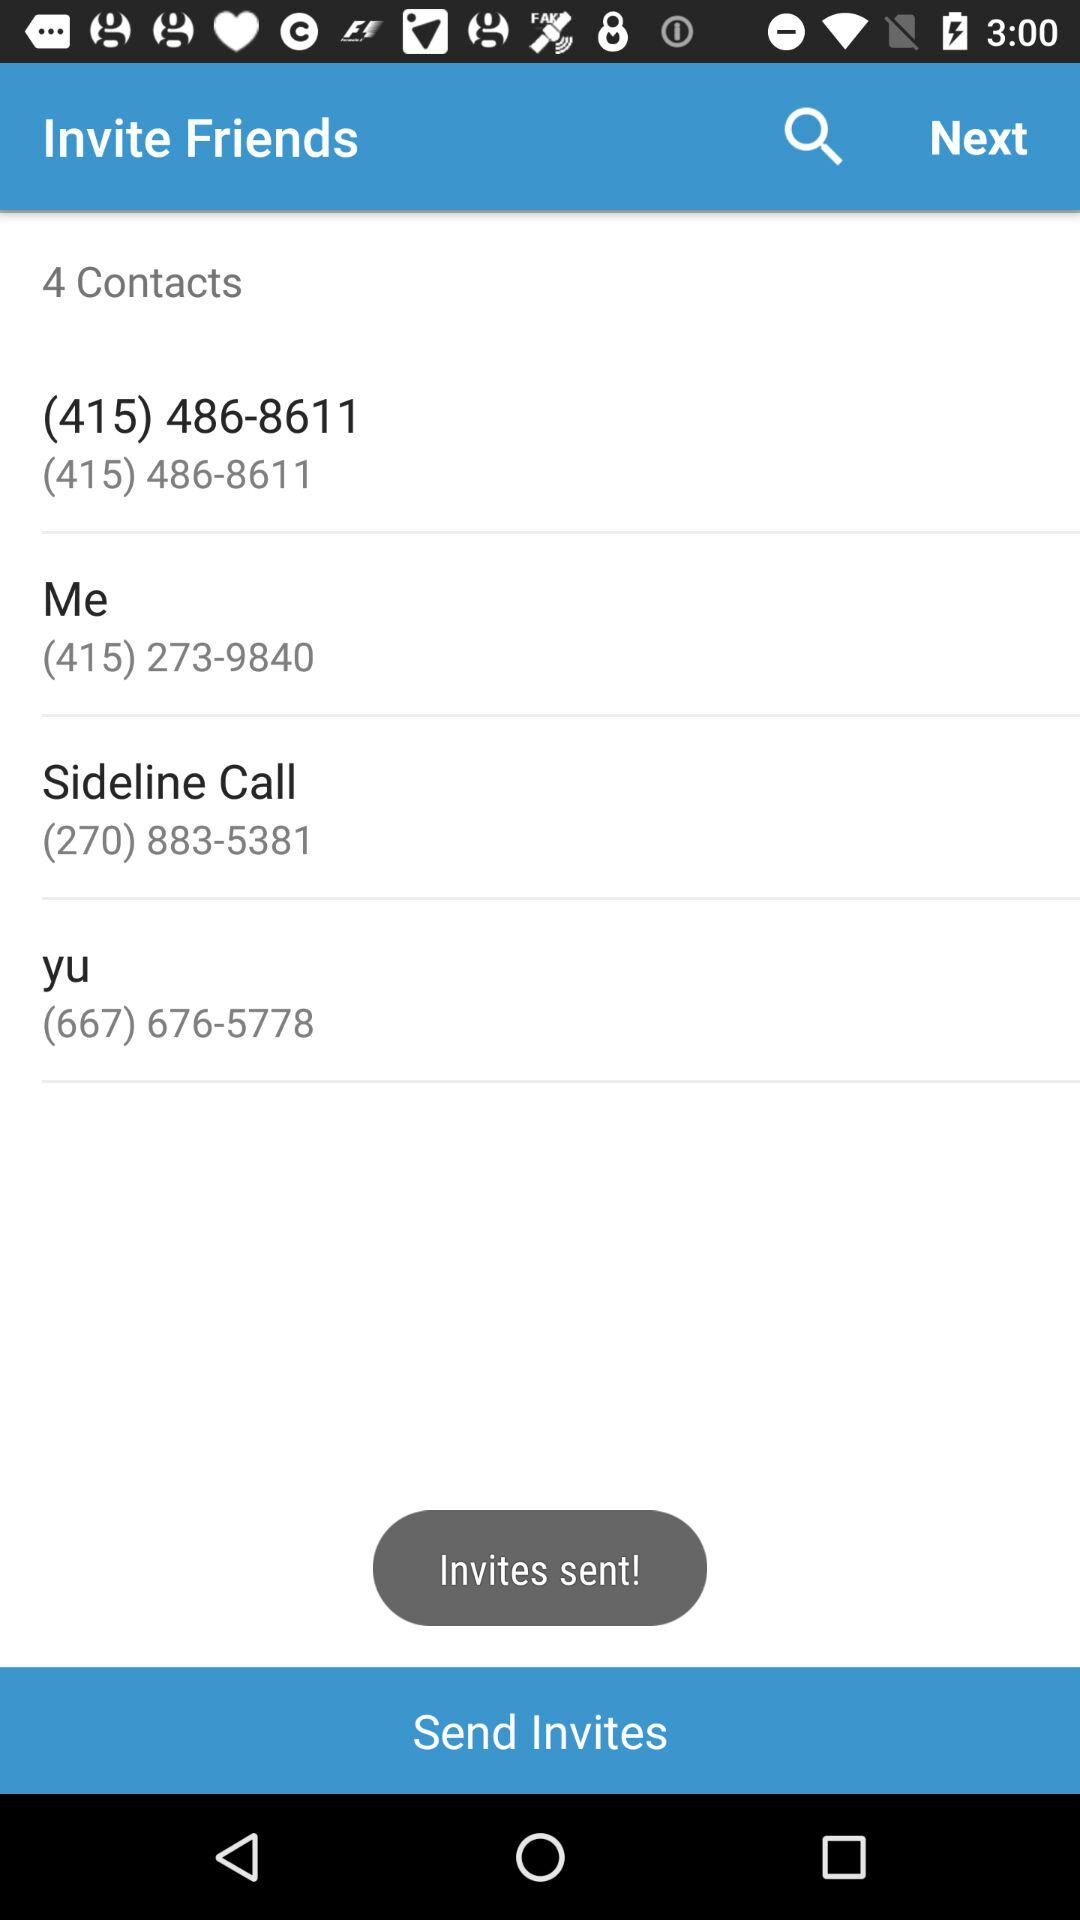How many contacts are given? There are 4 contacts. 